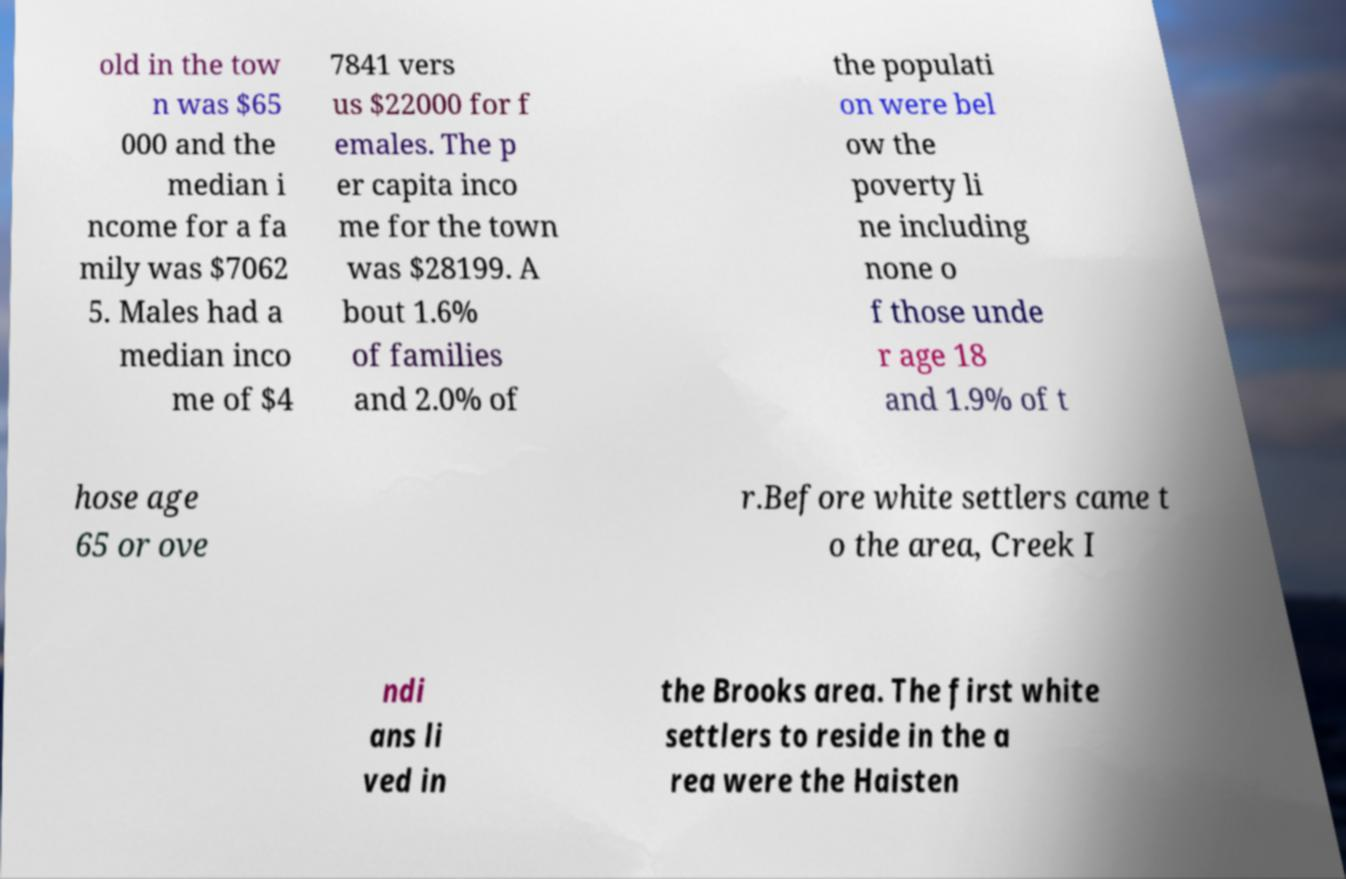For documentation purposes, I need the text within this image transcribed. Could you provide that? old in the tow n was $65 000 and the median i ncome for a fa mily was $7062 5. Males had a median inco me of $4 7841 vers us $22000 for f emales. The p er capita inco me for the town was $28199. A bout 1.6% of families and 2.0% of the populati on were bel ow the poverty li ne including none o f those unde r age 18 and 1.9% of t hose age 65 or ove r.Before white settlers came t o the area, Creek I ndi ans li ved in the Brooks area. The first white settlers to reside in the a rea were the Haisten 